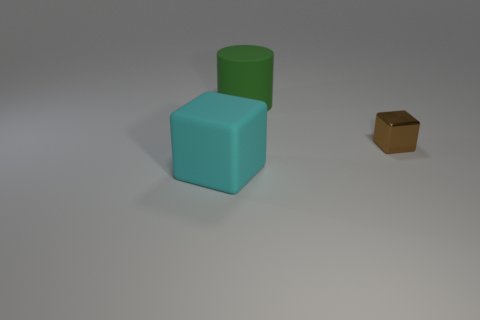How many things are either small blue metal balls or large matte cylinders?
Your answer should be compact. 1. Are there any big matte things of the same shape as the small object?
Your response must be concise. Yes. How many large rubber cylinders are in front of the brown block?
Provide a succinct answer. 0. What is the material of the block that is on the right side of the thing that is behind the tiny brown cube?
Offer a very short reply. Metal. There is a green cylinder that is the same size as the cyan cube; what is it made of?
Ensure brevity in your answer.  Rubber. Are there any things that have the same size as the matte cylinder?
Give a very brief answer. Yes. There is a block right of the green matte thing; what is its color?
Provide a succinct answer. Brown. There is a green cylinder on the right side of the large cyan block; is there a cyan thing that is behind it?
Provide a succinct answer. No. What number of other objects are there of the same color as the big matte cylinder?
Your response must be concise. 0. There is a rubber thing in front of the rubber cylinder; is it the same size as the cube that is right of the cyan object?
Offer a very short reply. No. 